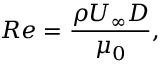Convert formula to latex. <formula><loc_0><loc_0><loc_500><loc_500>R e = \frac { \rho U _ { \infty } D } { \mu _ { 0 } } ,</formula> 